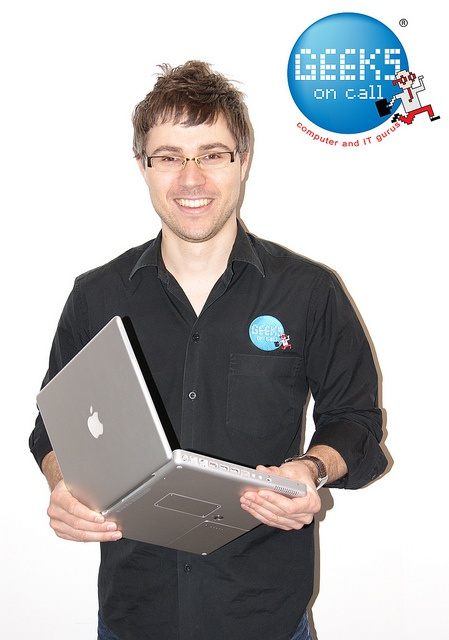Describe the objects in this image and their specific colors. I can see people in white, black, tan, and lightgray tones and laptop in white, darkgray, gray, and lightgray tones in this image. 